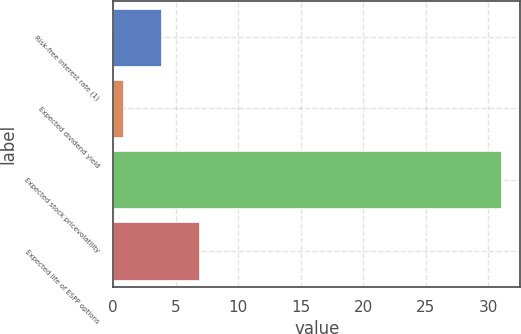Convert chart to OTSL. <chart><loc_0><loc_0><loc_500><loc_500><bar_chart><fcel>Risk-free interest rate (1)<fcel>Expected dividend yield<fcel>Expected stock pricevolatility<fcel>Expected life of ESPP options<nl><fcel>3.82<fcel>0.8<fcel>31<fcel>6.84<nl></chart> 